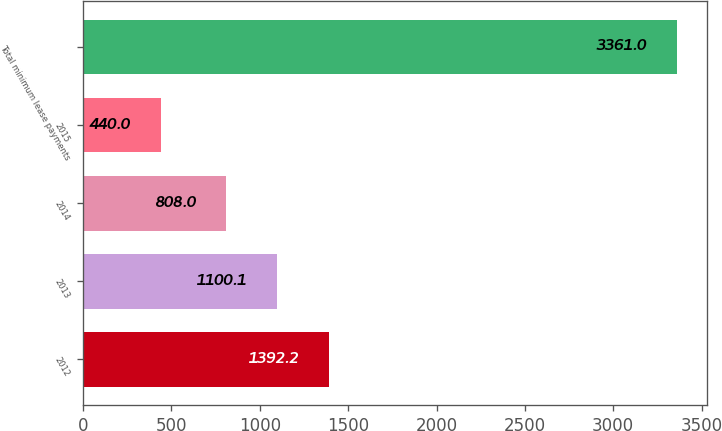Convert chart to OTSL. <chart><loc_0><loc_0><loc_500><loc_500><bar_chart><fcel>2012<fcel>2013<fcel>2014<fcel>2015<fcel>Total minimum lease payments<nl><fcel>1392.2<fcel>1100.1<fcel>808<fcel>440<fcel>3361<nl></chart> 